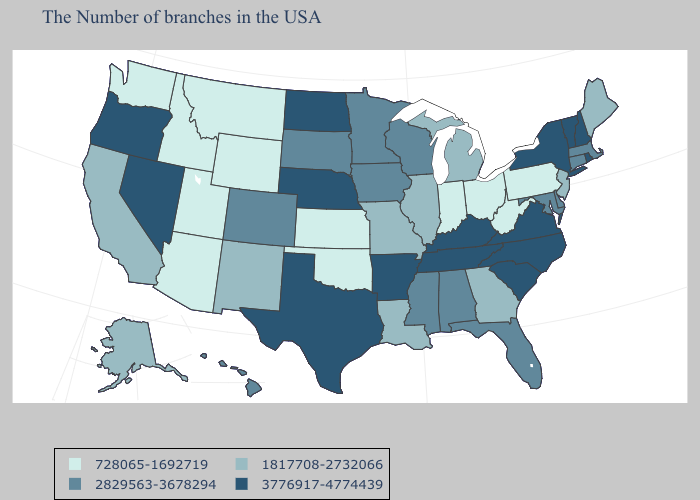What is the lowest value in the West?
Concise answer only. 728065-1692719. Does Ohio have the highest value in the USA?
Keep it brief. No. Is the legend a continuous bar?
Write a very short answer. No. Name the states that have a value in the range 3776917-4774439?
Short answer required. Rhode Island, New Hampshire, Vermont, New York, Virginia, North Carolina, South Carolina, Kentucky, Tennessee, Arkansas, Nebraska, Texas, North Dakota, Nevada, Oregon. Does Oregon have the highest value in the West?
Write a very short answer. Yes. What is the value of New York?
Quick response, please. 3776917-4774439. What is the value of Kentucky?
Be succinct. 3776917-4774439. Does California have a lower value than Oklahoma?
Keep it brief. No. What is the value of Wisconsin?
Give a very brief answer. 2829563-3678294. What is the value of Michigan?
Be succinct. 1817708-2732066. Does the map have missing data?
Write a very short answer. No. What is the value of Idaho?
Write a very short answer. 728065-1692719. What is the value of Hawaii?
Be succinct. 2829563-3678294. Name the states that have a value in the range 2829563-3678294?
Answer briefly. Massachusetts, Connecticut, Delaware, Maryland, Florida, Alabama, Wisconsin, Mississippi, Minnesota, Iowa, South Dakota, Colorado, Hawaii. 